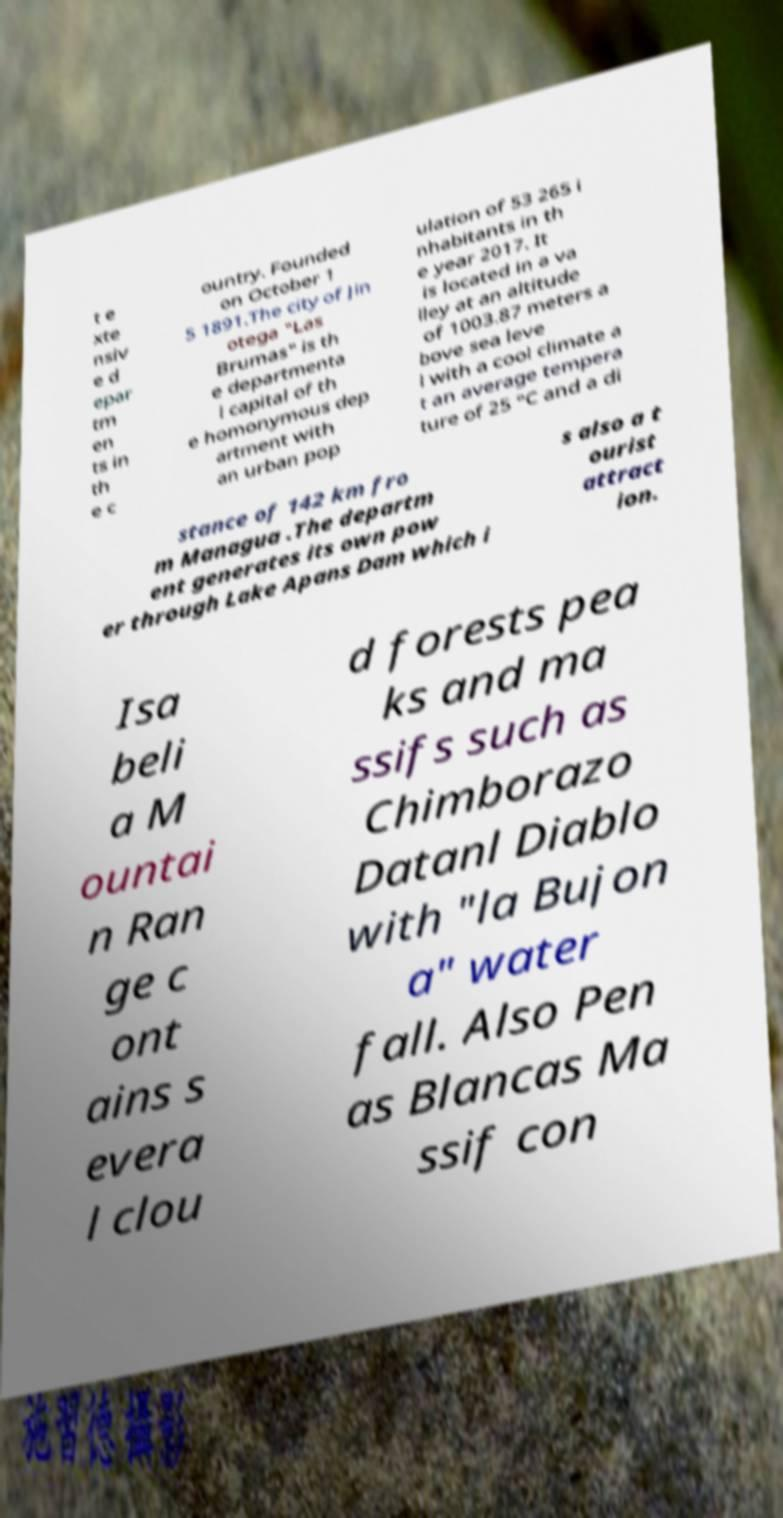Could you assist in decoding the text presented in this image and type it out clearly? t e xte nsiv e d epar tm en ts in th e c ountry. Founded on October 1 5 1891.The city of Jin otega "Las Brumas" is th e departmenta l capital of th e homonymous dep artment with an urban pop ulation of 53 265 i nhabitants in th e year 2017. It is located in a va lley at an altitude of 1003.87 meters a bove sea leve l with a cool climate a t an average tempera ture of 25 °C and a di stance of 142 km fro m Managua .The departm ent generates its own pow er through Lake Apans Dam which i s also a t ourist attract ion. Isa beli a M ountai n Ran ge c ont ains s evera l clou d forests pea ks and ma ssifs such as Chimborazo Datanl Diablo with "la Bujon a" water fall. Also Pen as Blancas Ma ssif con 